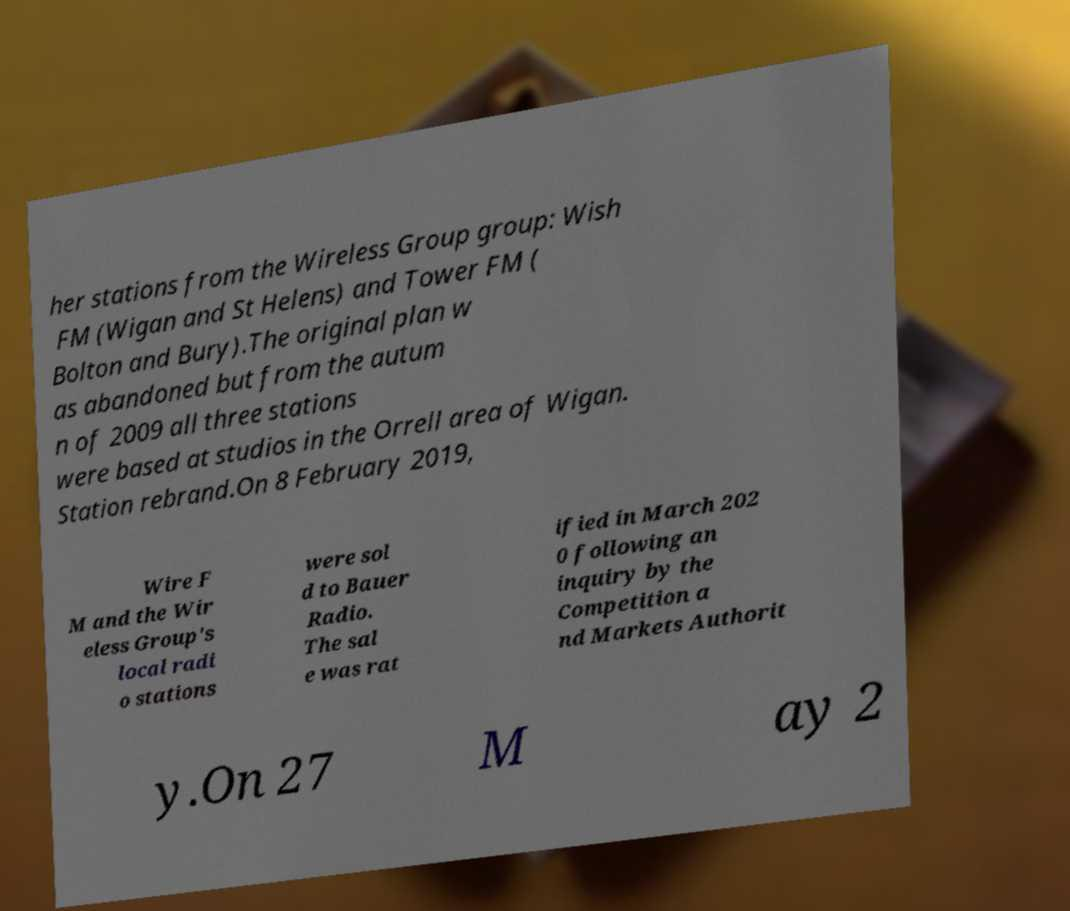Please identify and transcribe the text found in this image. her stations from the Wireless Group group: Wish FM (Wigan and St Helens) and Tower FM ( Bolton and Bury).The original plan w as abandoned but from the autum n of 2009 all three stations were based at studios in the Orrell area of Wigan. Station rebrand.On 8 February 2019, Wire F M and the Wir eless Group's local radi o stations were sol d to Bauer Radio. The sal e was rat ified in March 202 0 following an inquiry by the Competition a nd Markets Authorit y.On 27 M ay 2 